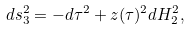<formula> <loc_0><loc_0><loc_500><loc_500>d s _ { 3 } ^ { 2 } = - d \tau ^ { 2 } + z ( \tau ) ^ { 2 } d H _ { 2 } ^ { 2 } ,</formula> 